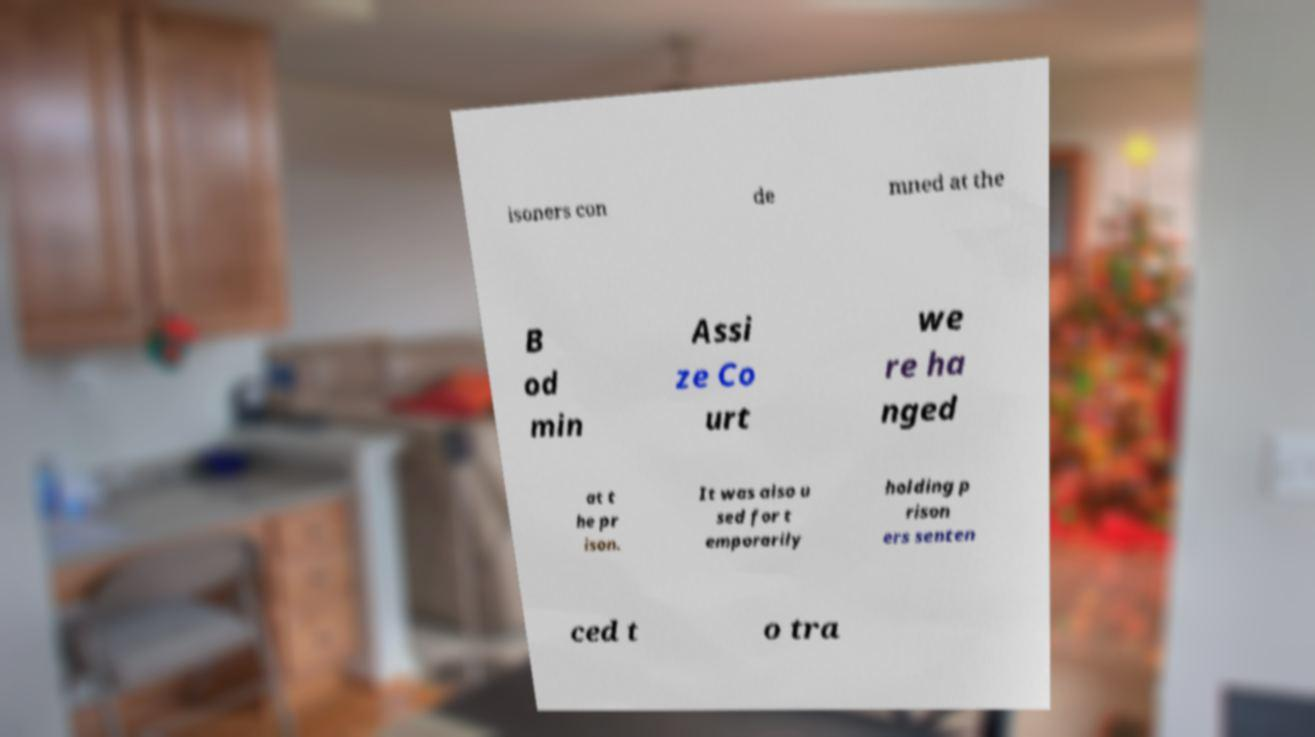Please identify and transcribe the text found in this image. isoners con de mned at the B od min Assi ze Co urt we re ha nged at t he pr ison. It was also u sed for t emporarily holding p rison ers senten ced t o tra 